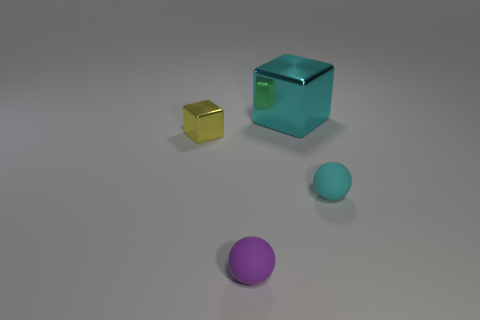Do the matte ball behind the purple sphere and the large metal object have the same color?
Ensure brevity in your answer.  Yes. What is the shape of the small object that is the same color as the big object?
Provide a succinct answer. Sphere. There is a small matte ball behind the rubber thing in front of the cyan rubber ball; how many cyan things are behind it?
Give a very brief answer. 1. What is the size of the cyan thing that is in front of the cyan object that is left of the cyan matte thing?
Your answer should be very brief. Small. There is a cyan ball that is made of the same material as the small purple object; what size is it?
Offer a very short reply. Small. There is a thing that is both on the left side of the big shiny block and behind the purple thing; what is its shape?
Offer a terse response. Cube. Are there the same number of tiny spheres to the left of the tiny shiny thing and cyan metallic spheres?
Give a very brief answer. Yes. How many things are brown rubber things or cyan matte balls in front of the big metallic cube?
Offer a very short reply. 1. Is there another cyan thing that has the same shape as the small cyan matte object?
Provide a short and direct response. No. Is the number of rubber objects that are to the right of the purple rubber sphere the same as the number of big blocks that are in front of the large cyan thing?
Ensure brevity in your answer.  No. 